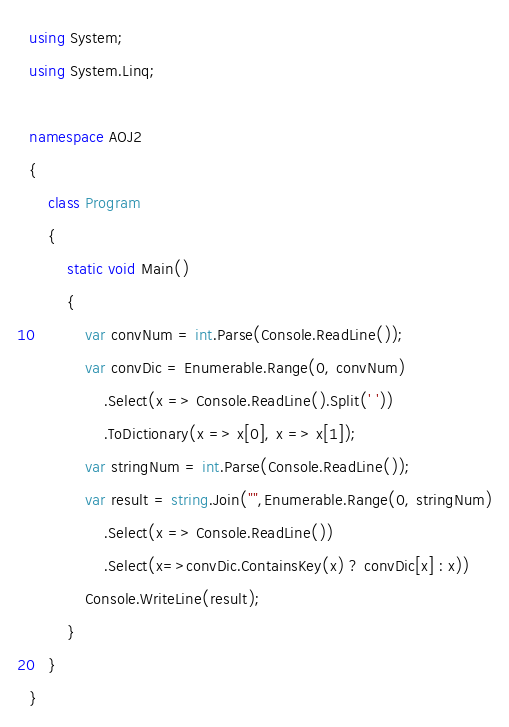Convert code to text. <code><loc_0><loc_0><loc_500><loc_500><_C#_>using System;
using System.Linq;

namespace AOJ2
{
    class Program
    {
        static void Main()
        {
            var convNum = int.Parse(Console.ReadLine());
            var convDic = Enumerable.Range(0, convNum)
                .Select(x => Console.ReadLine().Split(' '))
                .ToDictionary(x => x[0], x => x[1]);
            var stringNum = int.Parse(Console.ReadLine());
            var result = string.Join("",Enumerable.Range(0, stringNum)
                .Select(x => Console.ReadLine())
                .Select(x=>convDic.ContainsKey(x) ? convDic[x] : x))
            Console.WriteLine(result);
        }
    }
}</code> 